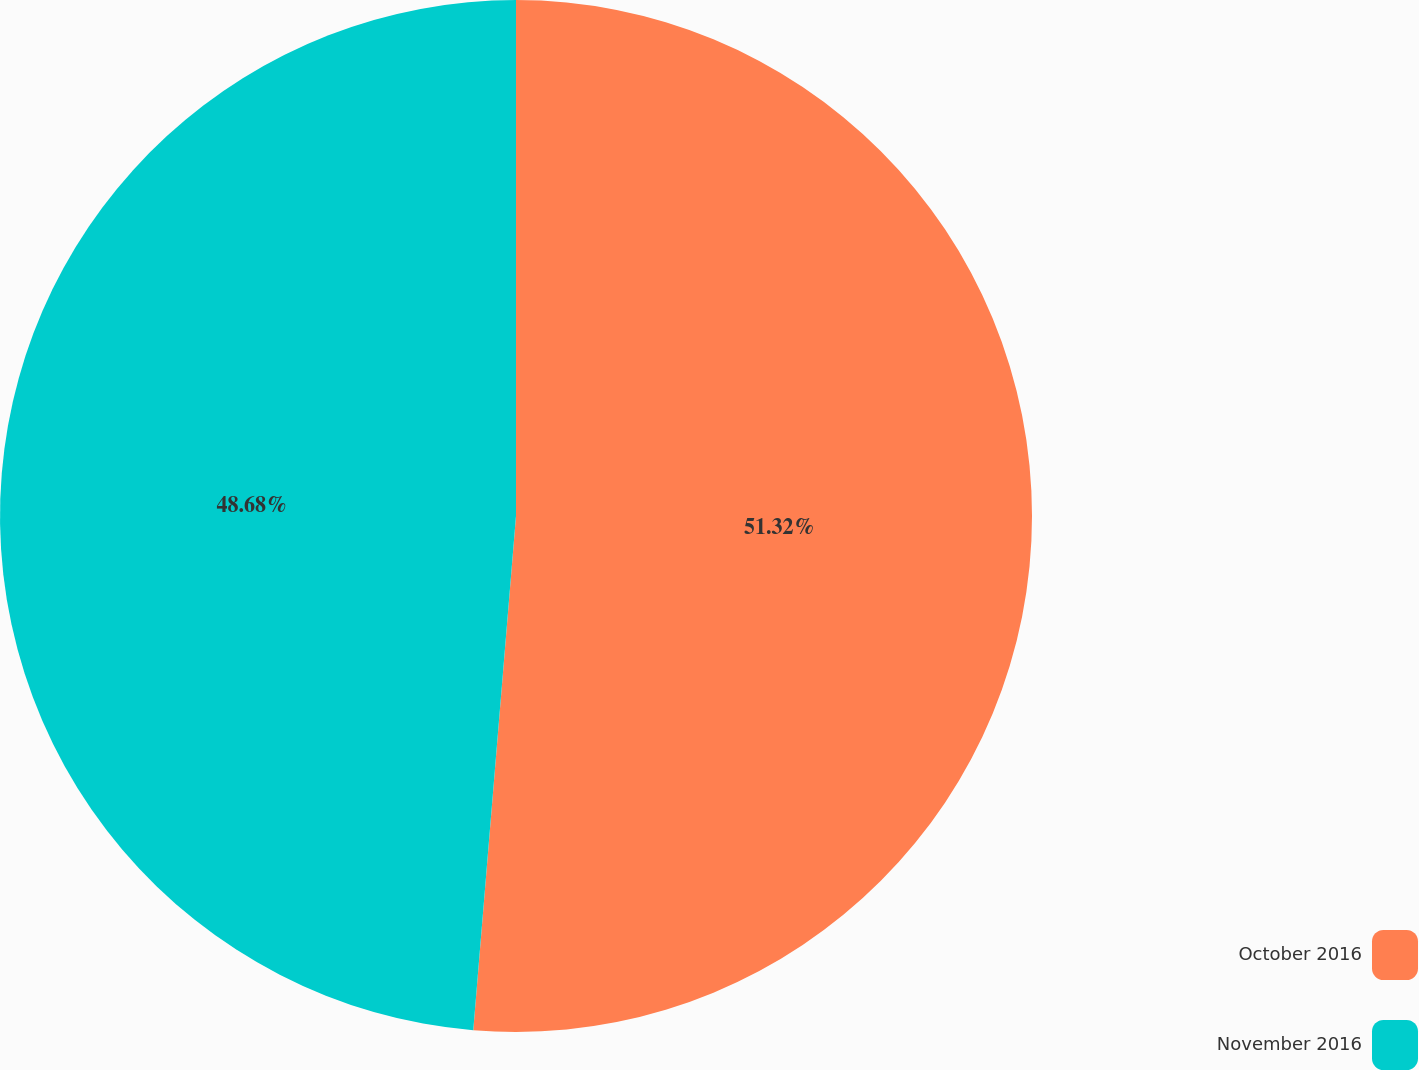Convert chart to OTSL. <chart><loc_0><loc_0><loc_500><loc_500><pie_chart><fcel>October 2016<fcel>November 2016<nl><fcel>51.32%<fcel>48.68%<nl></chart> 